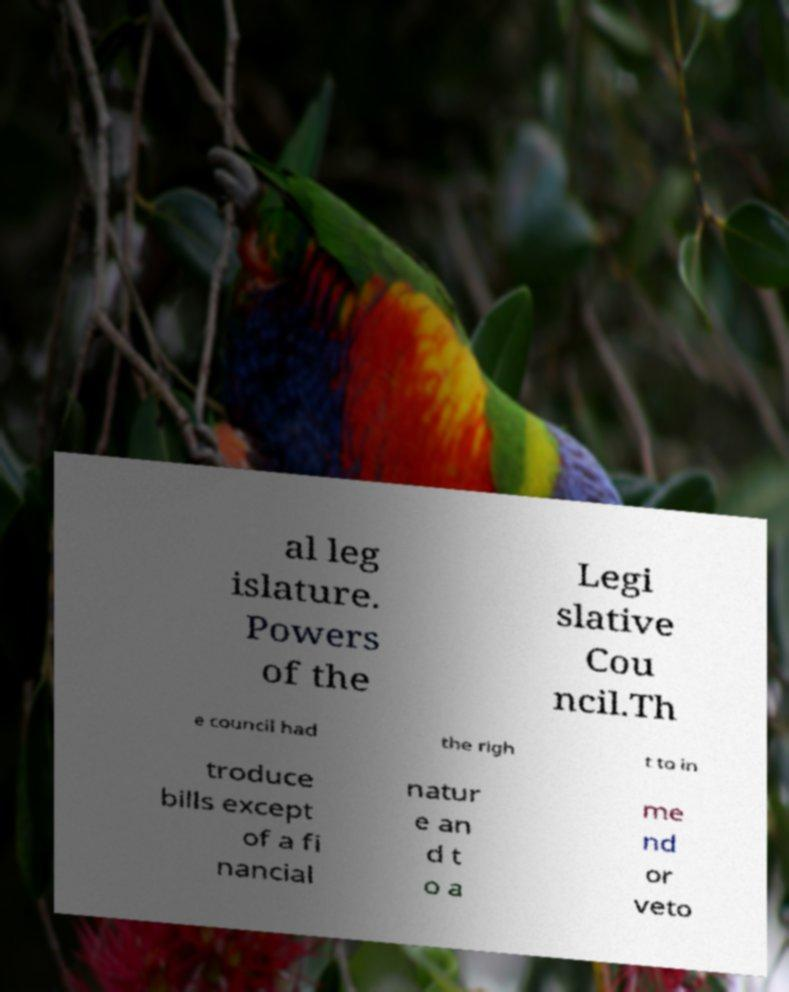Please identify and transcribe the text found in this image. al leg islature. Powers of the Legi slative Cou ncil.Th e council had the righ t to in troduce bills except of a fi nancial natur e an d t o a me nd or veto 